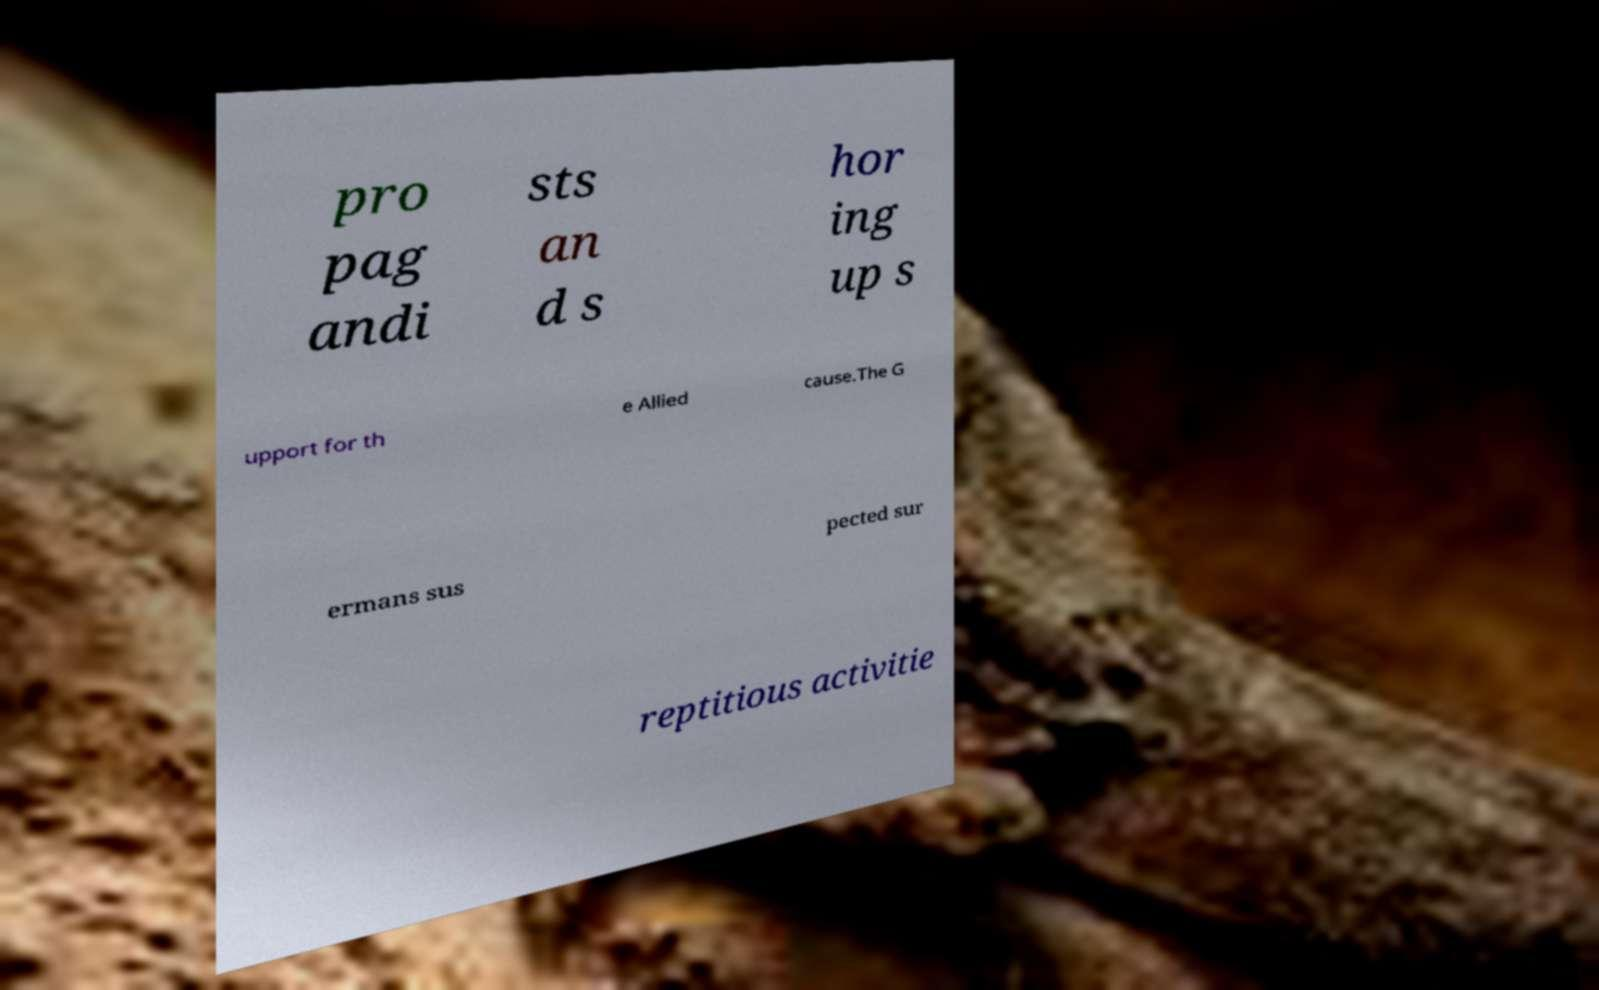For documentation purposes, I need the text within this image transcribed. Could you provide that? pro pag andi sts an d s hor ing up s upport for th e Allied cause.The G ermans sus pected sur reptitious activitie 